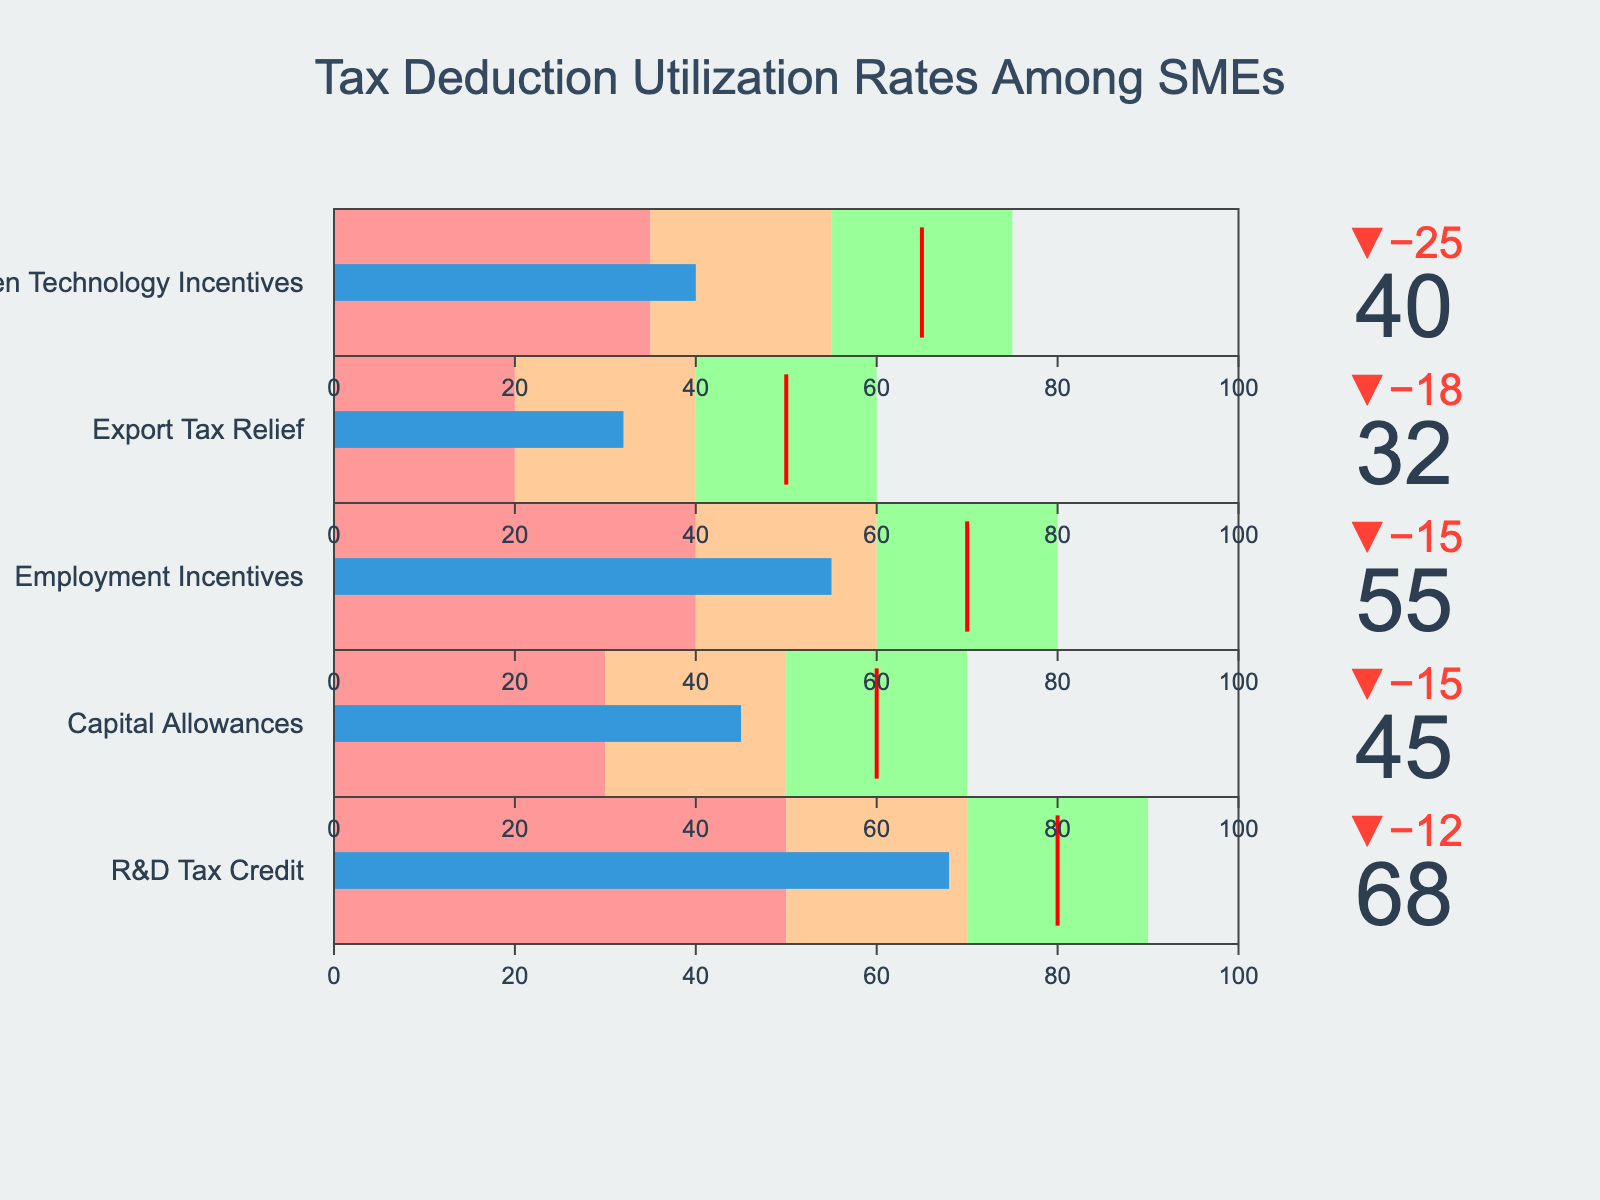What's the title of the figure? The title is displayed at the top of the figure and reads "Tax Deduction Utilization Rates Among SMEs."
Answer: Tax Deduction Utilization Rates Among SMEs Which tax deduction category has the highest actual utilization rate? Review each bullet graph under the various categories to find the one with the highest value. The highest actual utilization rate is 68 for the "R&D Tax Credit" category.
Answer: R&D Tax Credit By how much does the R&D Tax Credit utilization rate fall short of the target? The target rate for the R&D Tax Credit is 80, while the actual rate is 68. The shortfall is calculated as 80 - 68.
Answer: 12 What is the average actual utilization rate across all categories? Sum the actual utilization rates for all categories: 68, 45, 55, 32, 40. Then divide by the number of categories (5). Average = (68 + 45 + 55 + 32 + 40) / 5 = 48.
Answer: 48 Which category is closest to meeting its target utilization rate? Determine the difference between the actual and target rates for each category. The category with the smallest difference is the closest. The smallest difference is 12 for the "R&D Tax Credit."
Answer: R&D Tax Credit How many categories have an actual utilization rate below 50? Count the categories where the actual utilization rate is less than 50. They are "Capital Allowances," "Export Tax Relief," and "Green Technology Incentives."
Answer: 3 Among the listed categories, which one has the poorest performance in terms of actual utilization rate compared to its target? Calculate the difference between actual and target for each category. The category with the largest shortfall is "Export Tax Relief" with a target of 50 and an actual rate of 32. The shortfall is 18.
Answer: Export Tax Relief Which categories have utilization rates that fall within the satisfactory range? Check each bullet chart to see where the actual rate falls relative to the shaded zones. "R&D Tax Credit," "Capital Allowances," and "Employment Incentives" fall within their satisfactory ranges.
Answer: R&D Tax Credit, Capital Allowances, Employment Incentives 